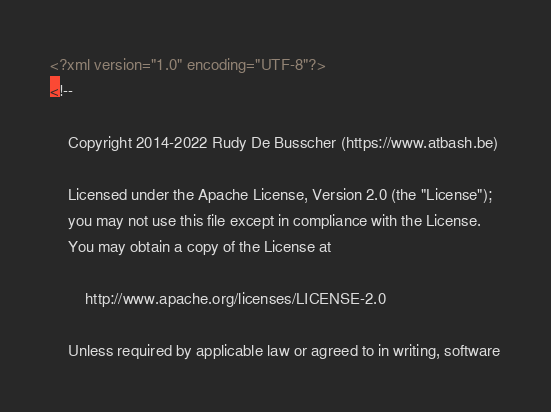<code> <loc_0><loc_0><loc_500><loc_500><_XML_><?xml version="1.0" encoding="UTF-8"?>
<!--

    Copyright 2014-2022 Rudy De Busscher (https://www.atbash.be)

    Licensed under the Apache License, Version 2.0 (the "License");
    you may not use this file except in compliance with the License.
    You may obtain a copy of the License at

        http://www.apache.org/licenses/LICENSE-2.0

    Unless required by applicable law or agreed to in writing, software</code> 